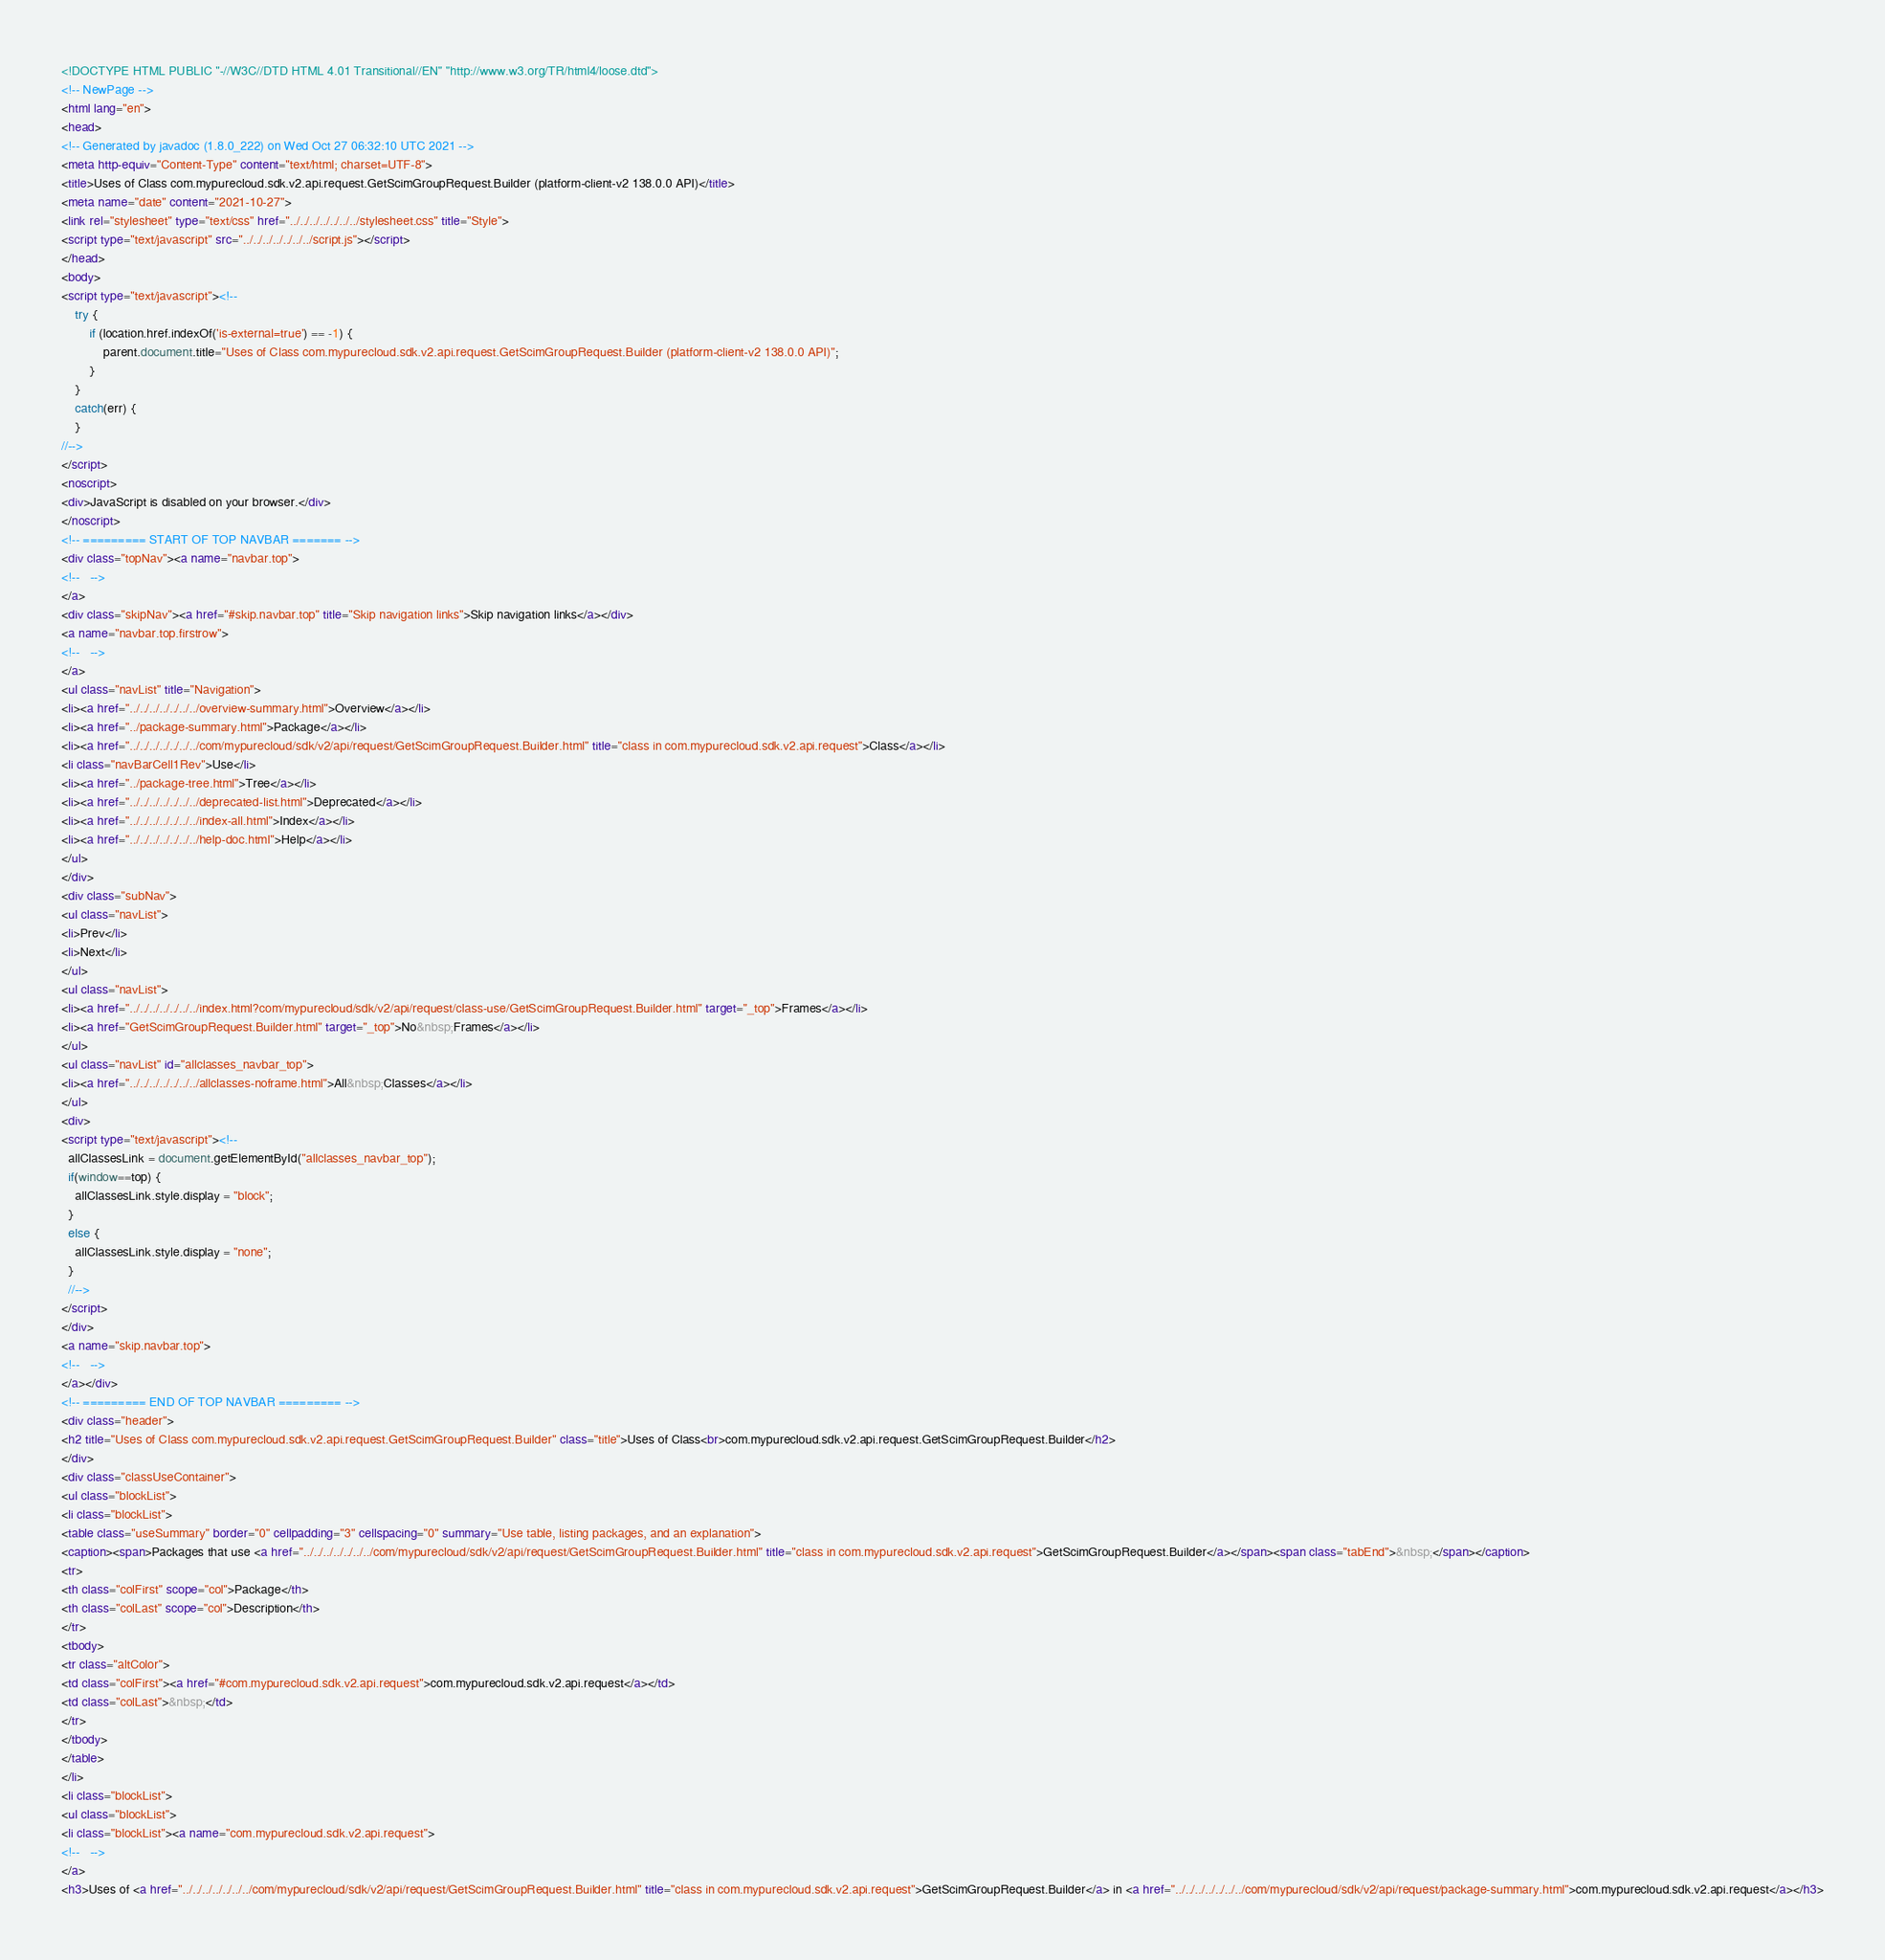Convert code to text. <code><loc_0><loc_0><loc_500><loc_500><_HTML_><!DOCTYPE HTML PUBLIC "-//W3C//DTD HTML 4.01 Transitional//EN" "http://www.w3.org/TR/html4/loose.dtd">
<!-- NewPage -->
<html lang="en">
<head>
<!-- Generated by javadoc (1.8.0_222) on Wed Oct 27 06:32:10 UTC 2021 -->
<meta http-equiv="Content-Type" content="text/html; charset=UTF-8">
<title>Uses of Class com.mypurecloud.sdk.v2.api.request.GetScimGroupRequest.Builder (platform-client-v2 138.0.0 API)</title>
<meta name="date" content="2021-10-27">
<link rel="stylesheet" type="text/css" href="../../../../../../../stylesheet.css" title="Style">
<script type="text/javascript" src="../../../../../../../script.js"></script>
</head>
<body>
<script type="text/javascript"><!--
    try {
        if (location.href.indexOf('is-external=true') == -1) {
            parent.document.title="Uses of Class com.mypurecloud.sdk.v2.api.request.GetScimGroupRequest.Builder (platform-client-v2 138.0.0 API)";
        }
    }
    catch(err) {
    }
//-->
</script>
<noscript>
<div>JavaScript is disabled on your browser.</div>
</noscript>
<!-- ========= START OF TOP NAVBAR ======= -->
<div class="topNav"><a name="navbar.top">
<!--   -->
</a>
<div class="skipNav"><a href="#skip.navbar.top" title="Skip navigation links">Skip navigation links</a></div>
<a name="navbar.top.firstrow">
<!--   -->
</a>
<ul class="navList" title="Navigation">
<li><a href="../../../../../../../overview-summary.html">Overview</a></li>
<li><a href="../package-summary.html">Package</a></li>
<li><a href="../../../../../../../com/mypurecloud/sdk/v2/api/request/GetScimGroupRequest.Builder.html" title="class in com.mypurecloud.sdk.v2.api.request">Class</a></li>
<li class="navBarCell1Rev">Use</li>
<li><a href="../package-tree.html">Tree</a></li>
<li><a href="../../../../../../../deprecated-list.html">Deprecated</a></li>
<li><a href="../../../../../../../index-all.html">Index</a></li>
<li><a href="../../../../../../../help-doc.html">Help</a></li>
</ul>
</div>
<div class="subNav">
<ul class="navList">
<li>Prev</li>
<li>Next</li>
</ul>
<ul class="navList">
<li><a href="../../../../../../../index.html?com/mypurecloud/sdk/v2/api/request/class-use/GetScimGroupRequest.Builder.html" target="_top">Frames</a></li>
<li><a href="GetScimGroupRequest.Builder.html" target="_top">No&nbsp;Frames</a></li>
</ul>
<ul class="navList" id="allclasses_navbar_top">
<li><a href="../../../../../../../allclasses-noframe.html">All&nbsp;Classes</a></li>
</ul>
<div>
<script type="text/javascript"><!--
  allClassesLink = document.getElementById("allclasses_navbar_top");
  if(window==top) {
    allClassesLink.style.display = "block";
  }
  else {
    allClassesLink.style.display = "none";
  }
  //-->
</script>
</div>
<a name="skip.navbar.top">
<!--   -->
</a></div>
<!-- ========= END OF TOP NAVBAR ========= -->
<div class="header">
<h2 title="Uses of Class com.mypurecloud.sdk.v2.api.request.GetScimGroupRequest.Builder" class="title">Uses of Class<br>com.mypurecloud.sdk.v2.api.request.GetScimGroupRequest.Builder</h2>
</div>
<div class="classUseContainer">
<ul class="blockList">
<li class="blockList">
<table class="useSummary" border="0" cellpadding="3" cellspacing="0" summary="Use table, listing packages, and an explanation">
<caption><span>Packages that use <a href="../../../../../../../com/mypurecloud/sdk/v2/api/request/GetScimGroupRequest.Builder.html" title="class in com.mypurecloud.sdk.v2.api.request">GetScimGroupRequest.Builder</a></span><span class="tabEnd">&nbsp;</span></caption>
<tr>
<th class="colFirst" scope="col">Package</th>
<th class="colLast" scope="col">Description</th>
</tr>
<tbody>
<tr class="altColor">
<td class="colFirst"><a href="#com.mypurecloud.sdk.v2.api.request">com.mypurecloud.sdk.v2.api.request</a></td>
<td class="colLast">&nbsp;</td>
</tr>
</tbody>
</table>
</li>
<li class="blockList">
<ul class="blockList">
<li class="blockList"><a name="com.mypurecloud.sdk.v2.api.request">
<!--   -->
</a>
<h3>Uses of <a href="../../../../../../../com/mypurecloud/sdk/v2/api/request/GetScimGroupRequest.Builder.html" title="class in com.mypurecloud.sdk.v2.api.request">GetScimGroupRequest.Builder</a> in <a href="../../../../../../../com/mypurecloud/sdk/v2/api/request/package-summary.html">com.mypurecloud.sdk.v2.api.request</a></h3></code> 